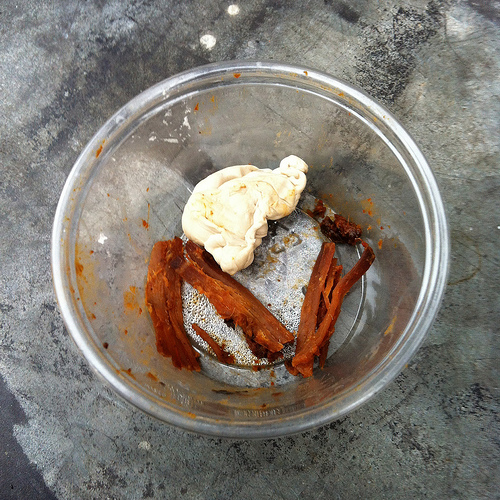<image>
Is the food in the bowl? Yes. The food is contained within or inside the bowl, showing a containment relationship. 